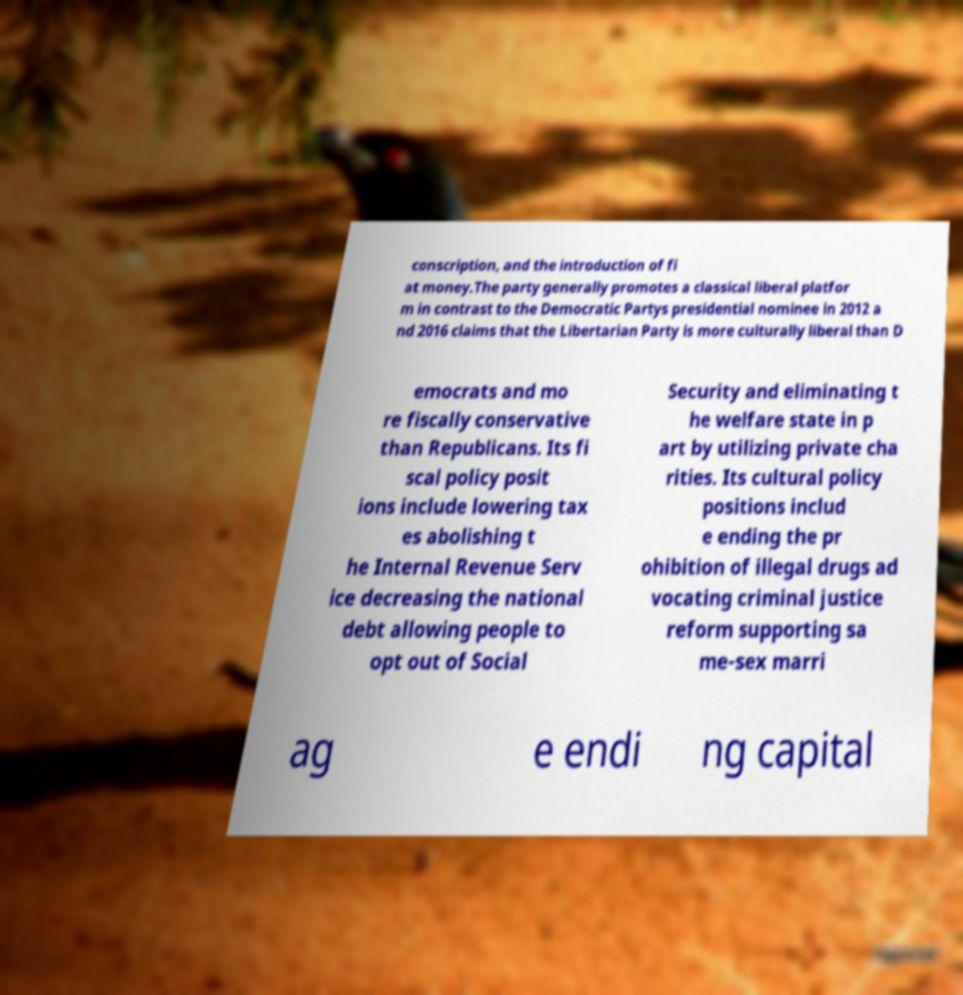Please read and relay the text visible in this image. What does it say? conscription, and the introduction of fi at money.The party generally promotes a classical liberal platfor m in contrast to the Democratic Partys presidential nominee in 2012 a nd 2016 claims that the Libertarian Party is more culturally liberal than D emocrats and mo re fiscally conservative than Republicans. Its fi scal policy posit ions include lowering tax es abolishing t he Internal Revenue Serv ice decreasing the national debt allowing people to opt out of Social Security and eliminating t he welfare state in p art by utilizing private cha rities. Its cultural policy positions includ e ending the pr ohibition of illegal drugs ad vocating criminal justice reform supporting sa me-sex marri ag e endi ng capital 